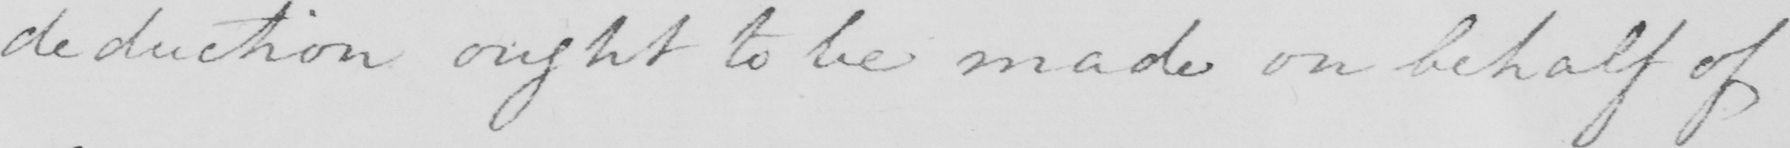Can you read and transcribe this handwriting? deduction ought to be made on behalf of 